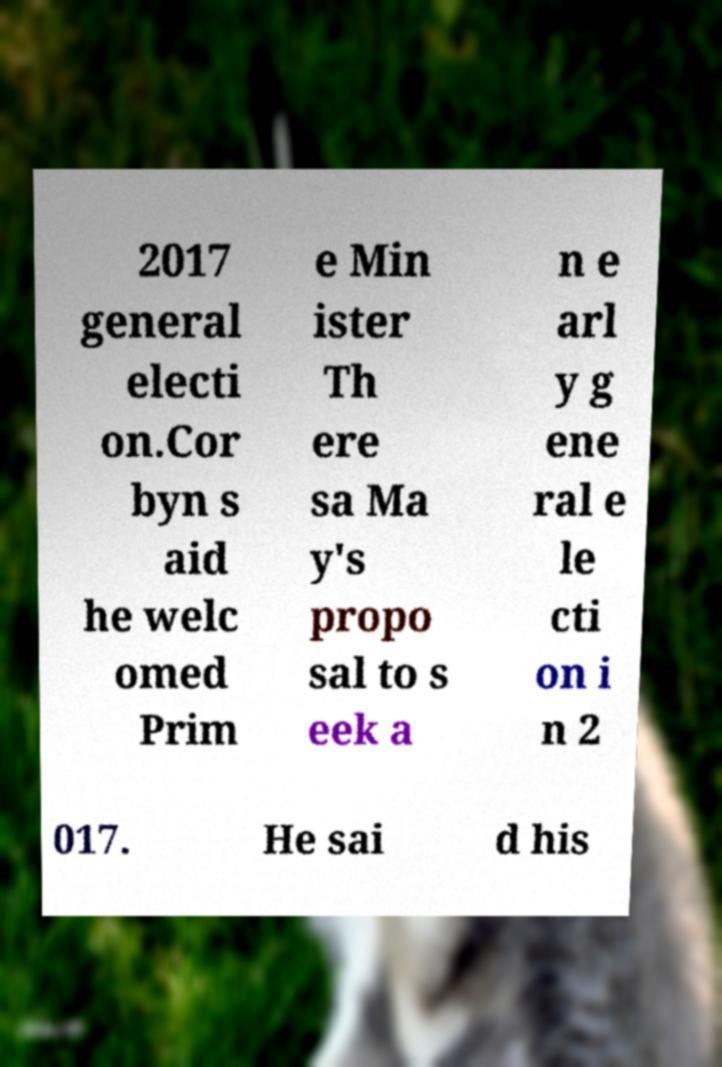For documentation purposes, I need the text within this image transcribed. Could you provide that? 2017 general electi on.Cor byn s aid he welc omed Prim e Min ister Th ere sa Ma y's propo sal to s eek a n e arl y g ene ral e le cti on i n 2 017. He sai d his 